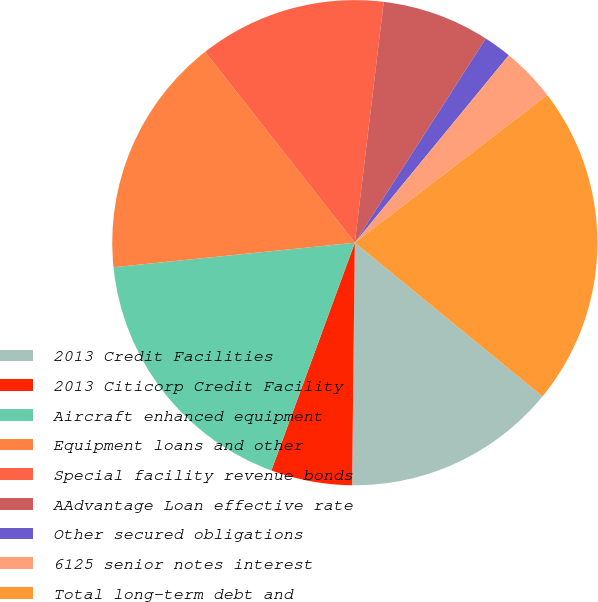Convert chart to OTSL. <chart><loc_0><loc_0><loc_500><loc_500><pie_chart><fcel>2013 Credit Facilities<fcel>2013 Citicorp Credit Facility<fcel>Aircraft enhanced equipment<fcel>Equipment loans and other<fcel>Special facility revenue bonds<fcel>AAdvantage Loan effective rate<fcel>Other secured obligations<fcel>6125 senior notes interest<fcel>Total long-term debt and<nl><fcel>14.26%<fcel>5.41%<fcel>17.8%<fcel>16.03%<fcel>12.49%<fcel>7.18%<fcel>1.87%<fcel>3.64%<fcel>21.34%<nl></chart> 